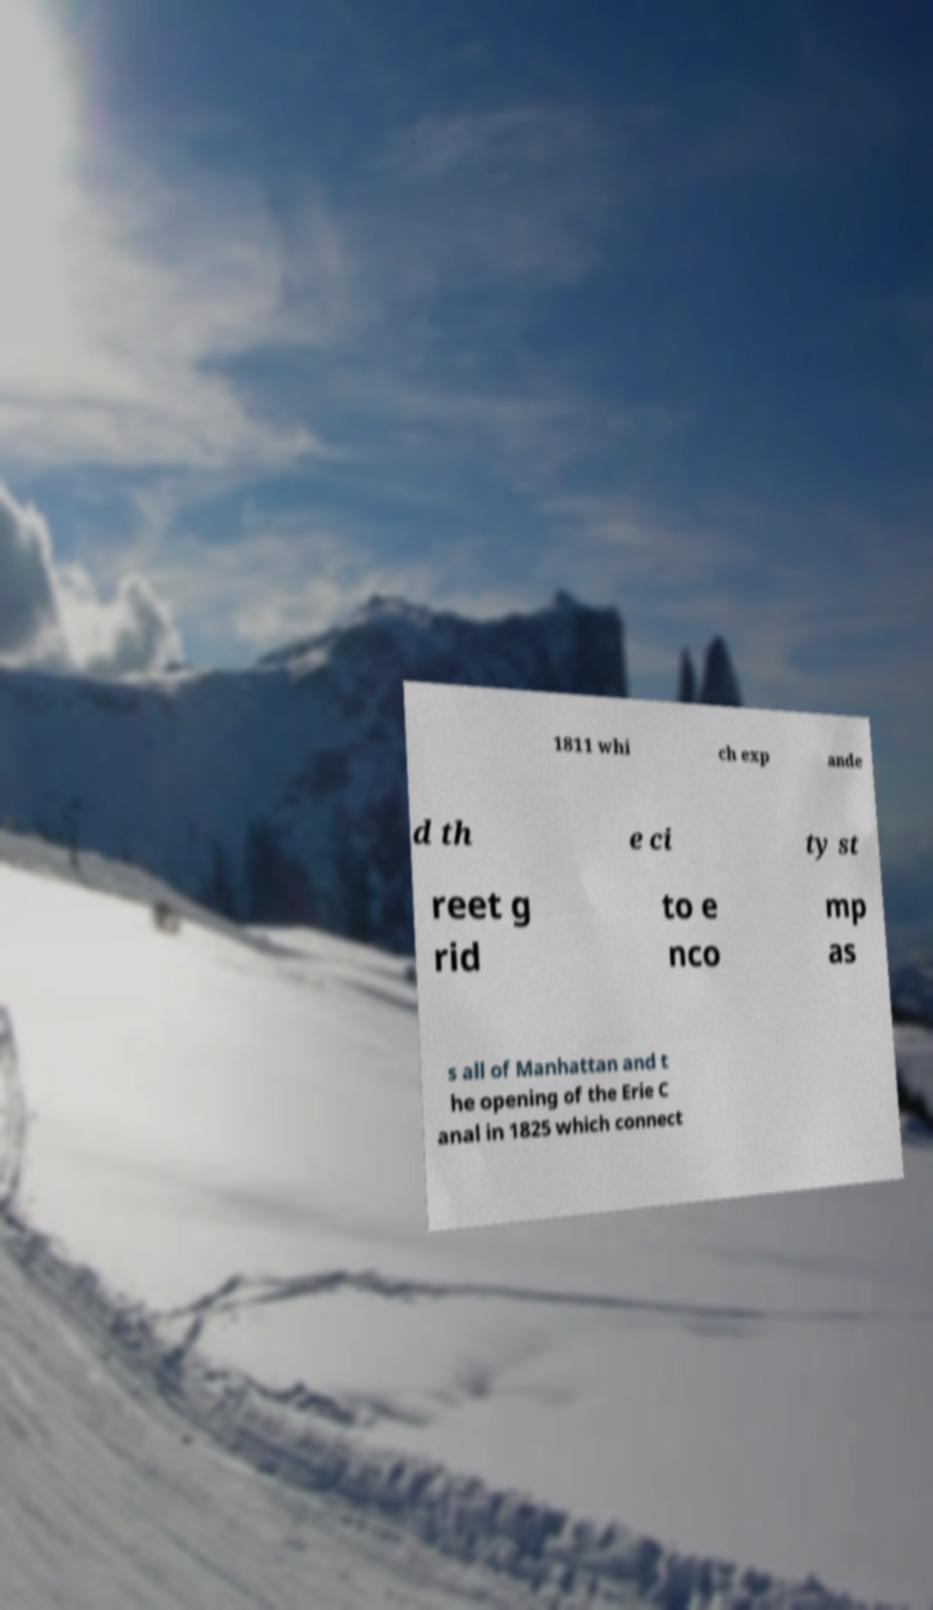Can you accurately transcribe the text from the provided image for me? 1811 whi ch exp ande d th e ci ty st reet g rid to e nco mp as s all of Manhattan and t he opening of the Erie C anal in 1825 which connect 